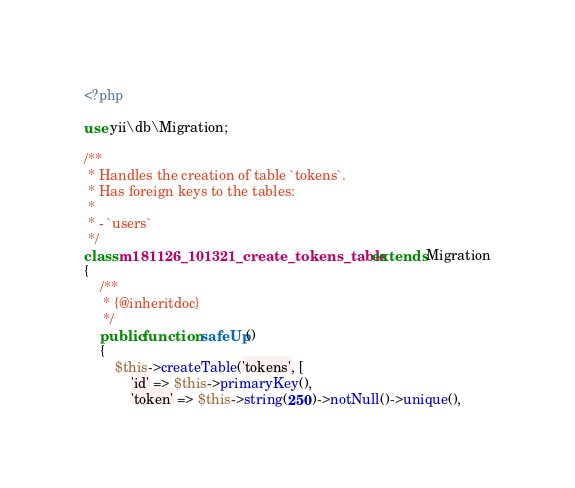<code> <loc_0><loc_0><loc_500><loc_500><_PHP_><?php

use yii\db\Migration;

/**
 * Handles the creation of table `tokens`.
 * Has foreign keys to the tables:
 *
 * - `users`
 */
class m181126_101321_create_tokens_table extends Migration
{
    /**
     * {@inheritdoc}
     */
    public function safeUp()
    {
        $this->createTable('tokens', [
            'id' => $this->primaryKey(),
            'token' => $this->string(250)->notNull()->unique(),</code> 